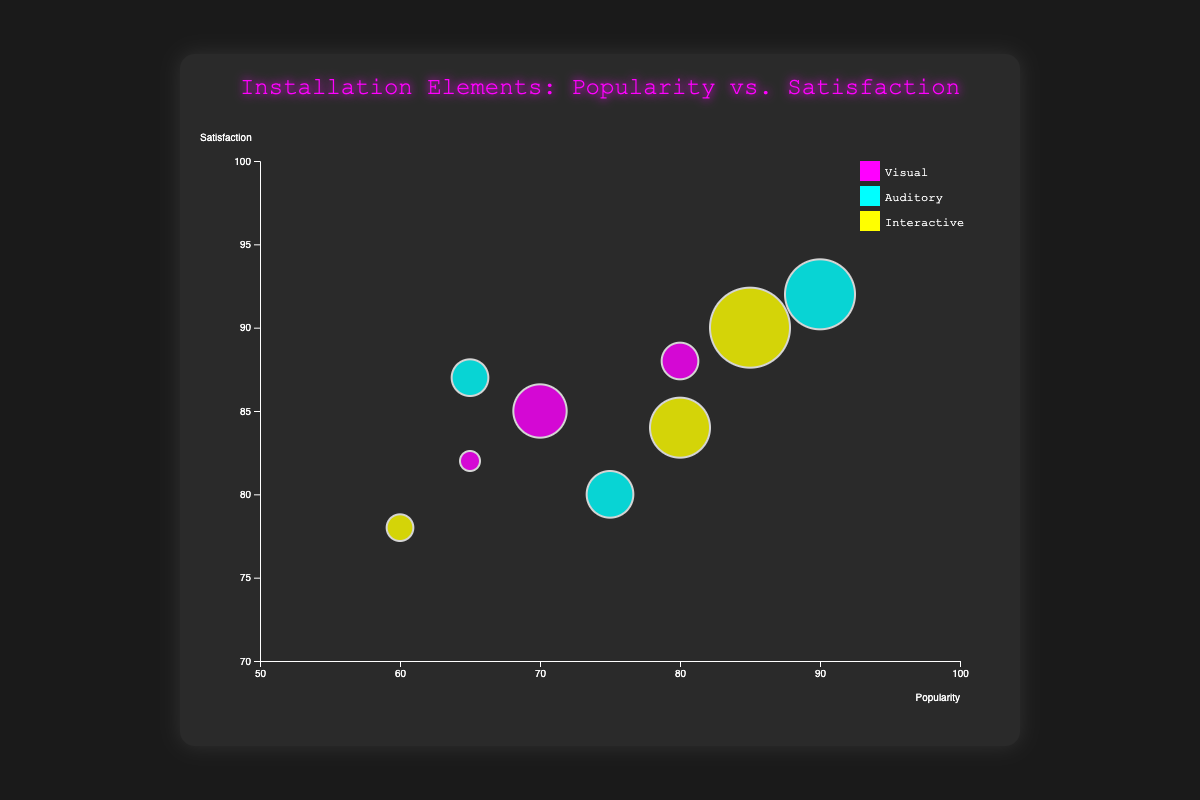How many data points represent Visual elements? By looking at the color used to represent Visual elements, which is magenta, we can count the number of bubbles with this color. There are three such bubbles representing LED Panels, Projection Mapping, and Sculptures.
Answer: 3 Which element has the highest viewer satisfaction? To find the element with the highest satisfaction, observe the y-axis values and locate the bubble at the highest position. Live Music, an auditory element, has the highest satisfaction at 92.
Answer: Live Music Which installation element has the largest impact on experience? The size of the bubbles represents the impact on experience. Identify the largest bubble, which corresponds to Virtual Reality with an impact of 88.
Answer: Virtual Reality Compare the popularity of Visual elements LED Panels and Projection Mapping. Which one is more popular? By comparing the x-axis values for the two specific Visual elements, LED Panels has a popularity score of 80, and Projection Mapping has a score of 70. Thus, LED Panels is more popular.
Answer: LED Panels Which Interactive element has the least viewer satisfaction? Observe the y-axis positions of the yellow-colored bubbles representing Interactive elements. Touch Sensors, Motion Capture, and Virtual Reality are located at different heights. Touch Sensors has the lowest satisfaction at 78.
Answer: Touch Sensors What is the average impact on experience for Auditory elements? Calculate the average of the impact on experience for the auditory elements: (85 + 78 + 75) / 3 equals approximately 79.33.
Answer: 79.33 Which type of element generally occupies the middle range of popularity values, and what might this suggest? Examine the x-axis range for any clustering patterns. Interactive elements (Touch Sensors, Motion Capture, Virtual Reality) generally occupy the middle range (60-85) of popularity scores. This suggests that Interactive elements have moderate popularity.
Answer: Interactive elements Is there any element that has both high popularity and high satisfaction? If so, which one? Look for bubbles that are positioned towards the top right corner of the chart. Live Music, with a popularity of 90 and satisfaction of 92, fulfills this criterion.
Answer: Live Music How does the satisfaction level of Soundscapes compare to that of Projection Mapping? Look at the y-axis values for both elements. Soundscapes has a satisfaction level of 80, while Projection Mapping has 85. Thus, Projection Mapping has a higher satisfaction level than Soundscapes.
Answer: Projection Mapping 